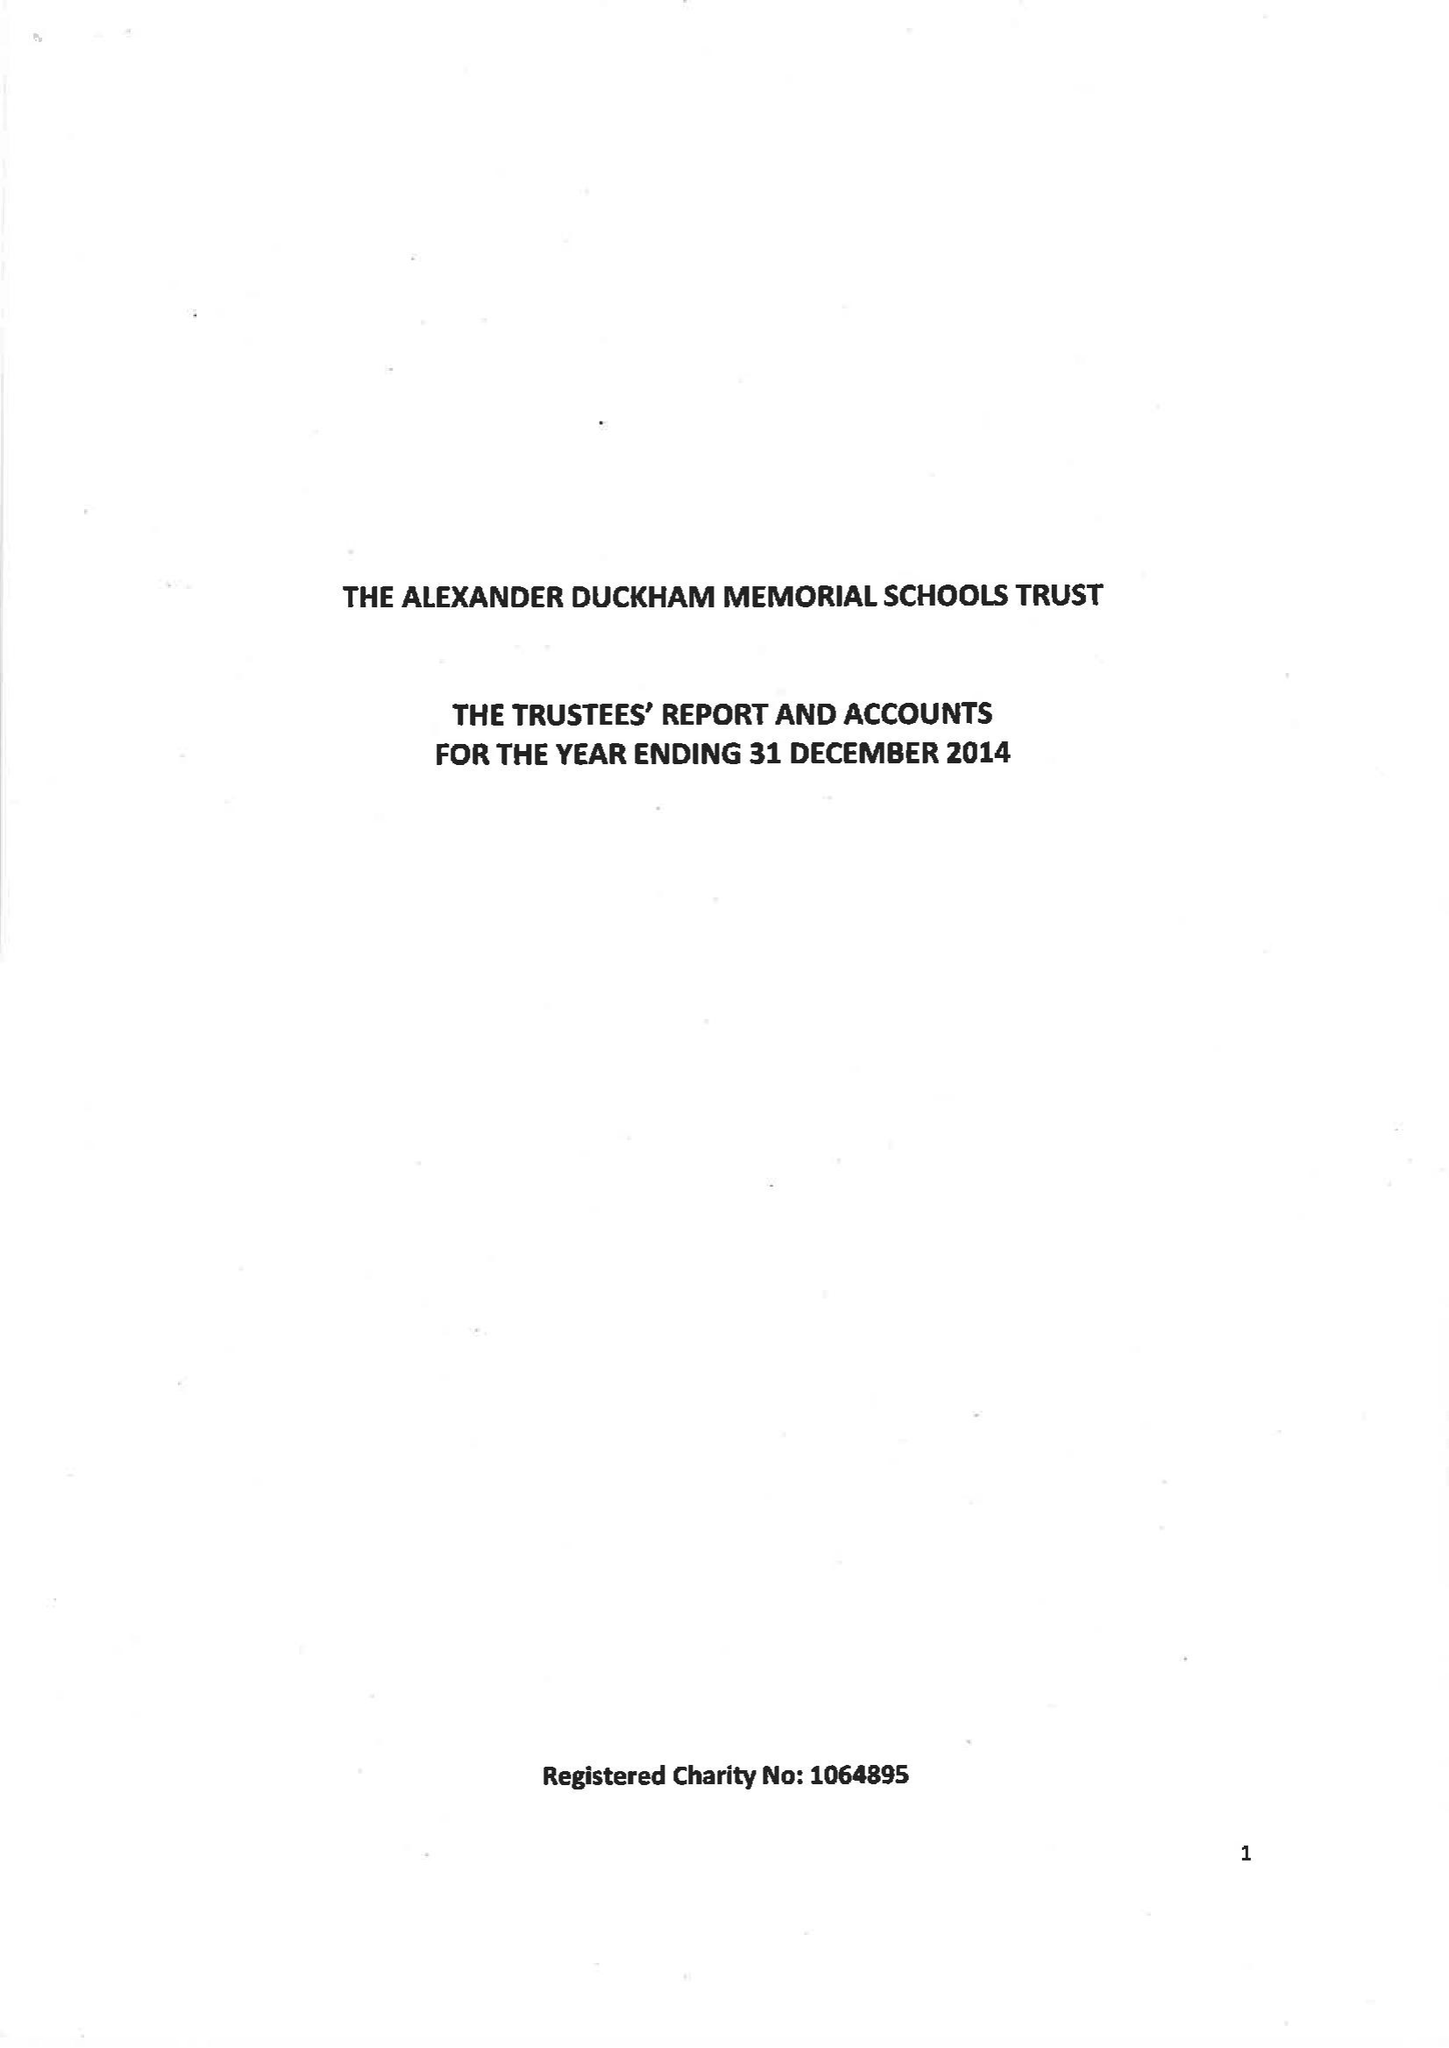What is the value for the address__post_town?
Answer the question using a single word or phrase. LONDON 